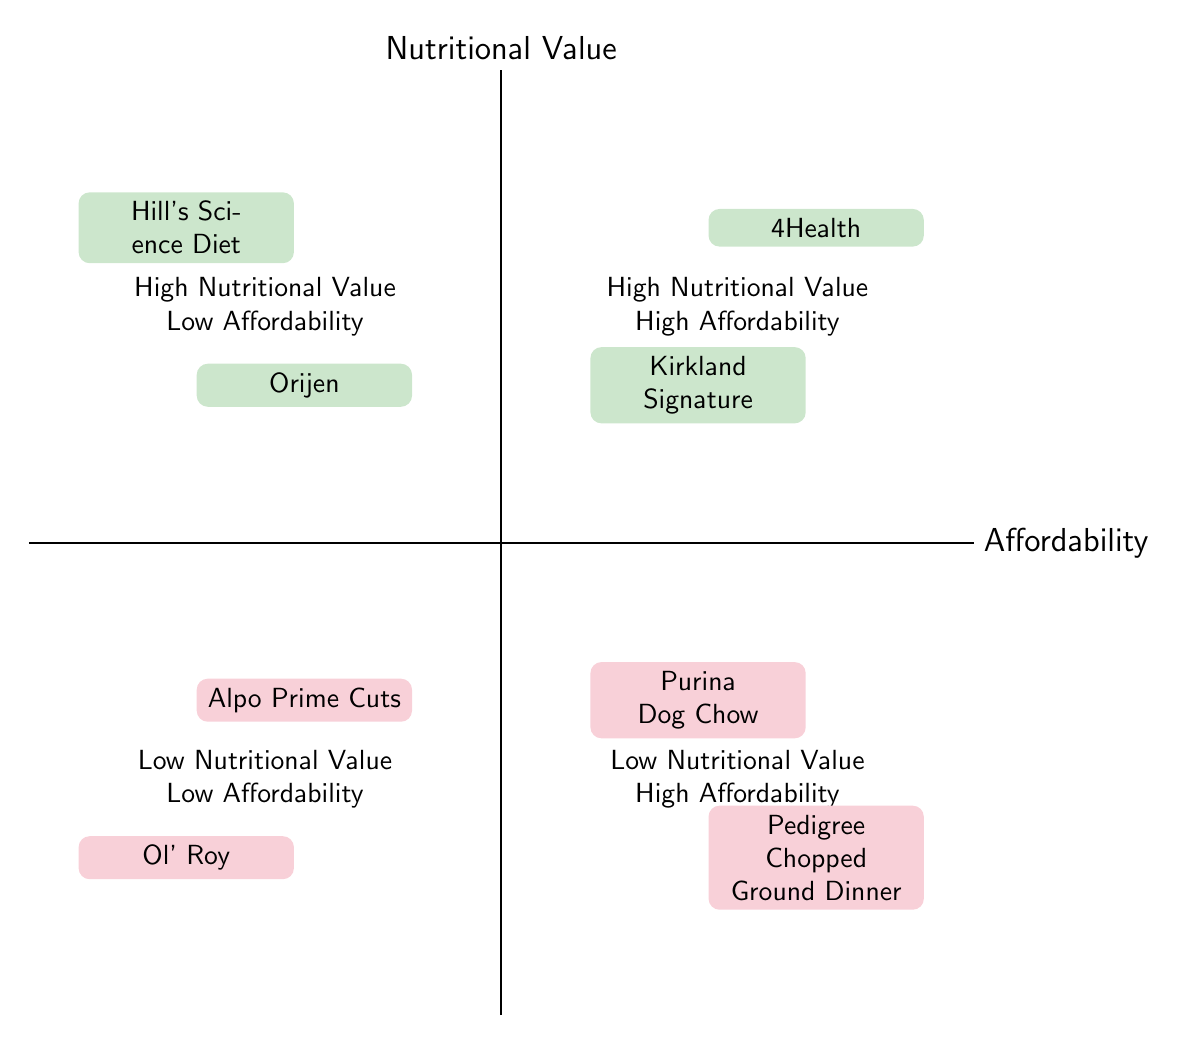What is the name of the food in the "High Nutritional Value High Affordability" quadrant? The diagram identifies two items in this quadrant: "Kirkland Signature" and "4Health". Since the question asks for the name of the food, we can refer to either of these names.
Answer: Kirkland Signature How many types of food are in the "Low Nutritional Value High Affordability" quadrant? There are two types of food listed in this quadrant: "Purina Dog Chow" and "Pedigree Chopped Ground Dinner". Counting them gives us a total of two.
Answer: 2 Which food is in the "High Nutritional Value Low Affordability" quadrant? In the quadrant for High Nutritional Value and Low Affordability, the foods listed are "Orijen" and "Hill's Science Diet". Either could be a valid answer, but commonly "Orijen" is referenced for its high quality.
Answer: Orijen Is "Ol' Roy" considered high or low in nutritional value according to the diagram? "Ol' Roy" is placed in the quadrant labeled "Low Nutritional Value Low Affordability", which categorizes it as low in nutritional value.
Answer: Low What distinguishes "4Health" from "Hill's Science Diet" in the quadrants? "4Health" appears in the High Nutritional Value High Affordability quadrant, while "Hill's Science Diet" is in the High Nutritional Value Low Affordability quadrant. This distinction is made based on their affordability; "4Health" is affordable but "Hill's Science Diet" is not.
Answer: Affordability Which quadrant contains foods that are highly affordable but have low nutritional value? The "Low Nutritional Value High Affordability" quadrant includes foods that are accessible in price but offer basic nutrition such as "Purina Dog Chow" and "Pedigree Chopped Ground Dinner".
Answer: Low Nutritional Value High Affordability What type of food is "Alpo Prime Cuts"? According to the diagram, "Alpo Prime Cuts" falls within the "Low Nutritional Value Low Affordability" quadrant and is categorized as a Dry Food.
Answer: Dry Food How many foods have high nutritional value in total? The quadrants listed have a total of four foods that exhibit high nutritional value: "Kirkland Signature", "4Health", "Orijen", and "Hill's Science Diet". Adding them gives a total of four.
Answer: 4 What is the key feature of "Purina Dog Chow"? In the diagram, "Purina Dog Chow" is categorized within the "Low Nutritional Value High Affordability" quadrant and is described as "Easily Available".
Answer: Easily Available 